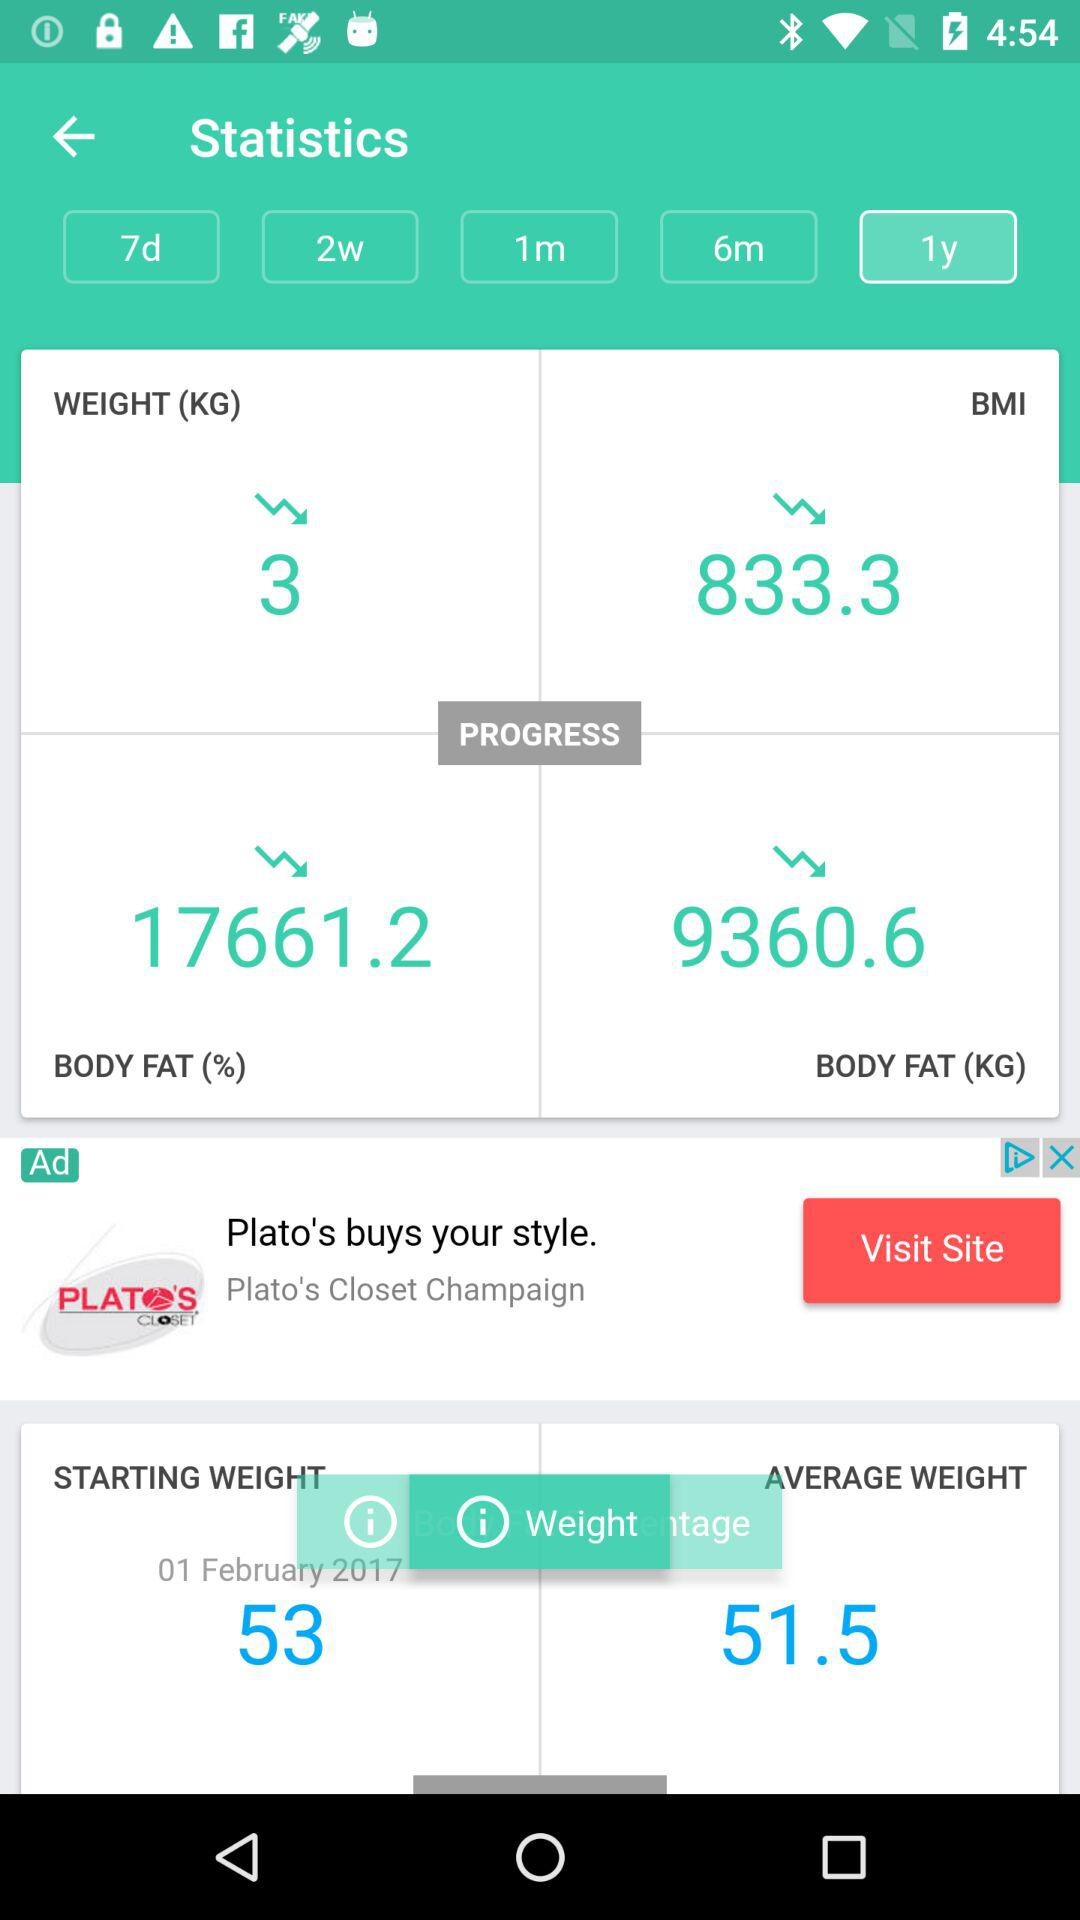Which option is selected in "Statistics"? The selected option is "1y". 